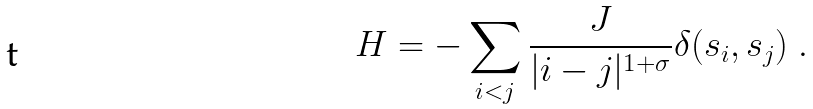<formula> <loc_0><loc_0><loc_500><loc_500>H = - \sum _ { i < j } \frac { J } { | i - j | ^ { 1 + \sigma } } \delta ( s _ { i } , s _ { j } ) \ .</formula> 